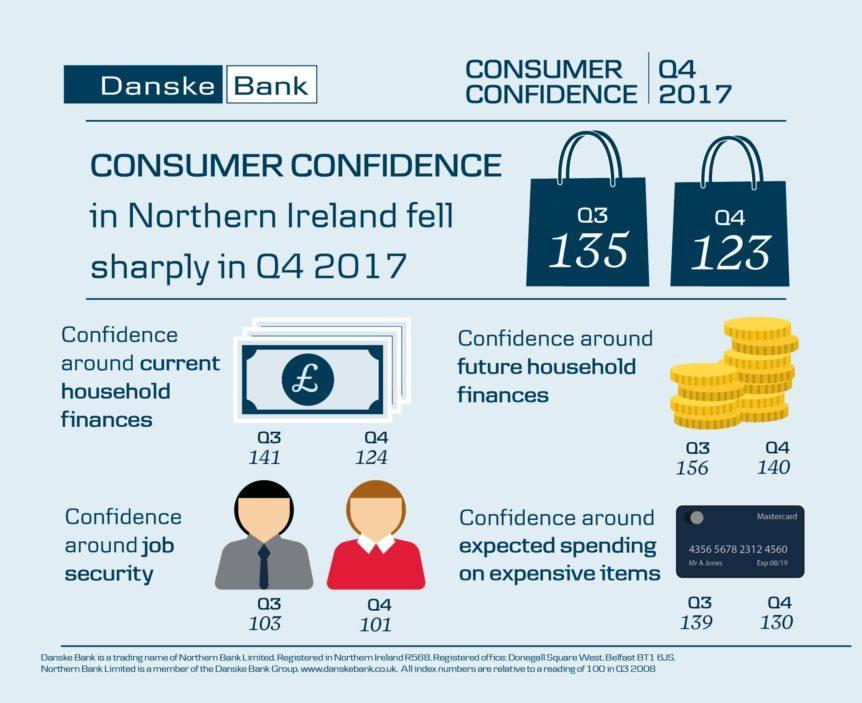What is the last four digits on the card?
Answer the question with a short phrase. 4560 What is the name of the financial services corporation mentioned on the card? Mastercard What was the difference in expected spending on expensive items between quarter 3 and quarter 4 ? 9 What was the consumer confidence in Ireland during quarter four? 123 